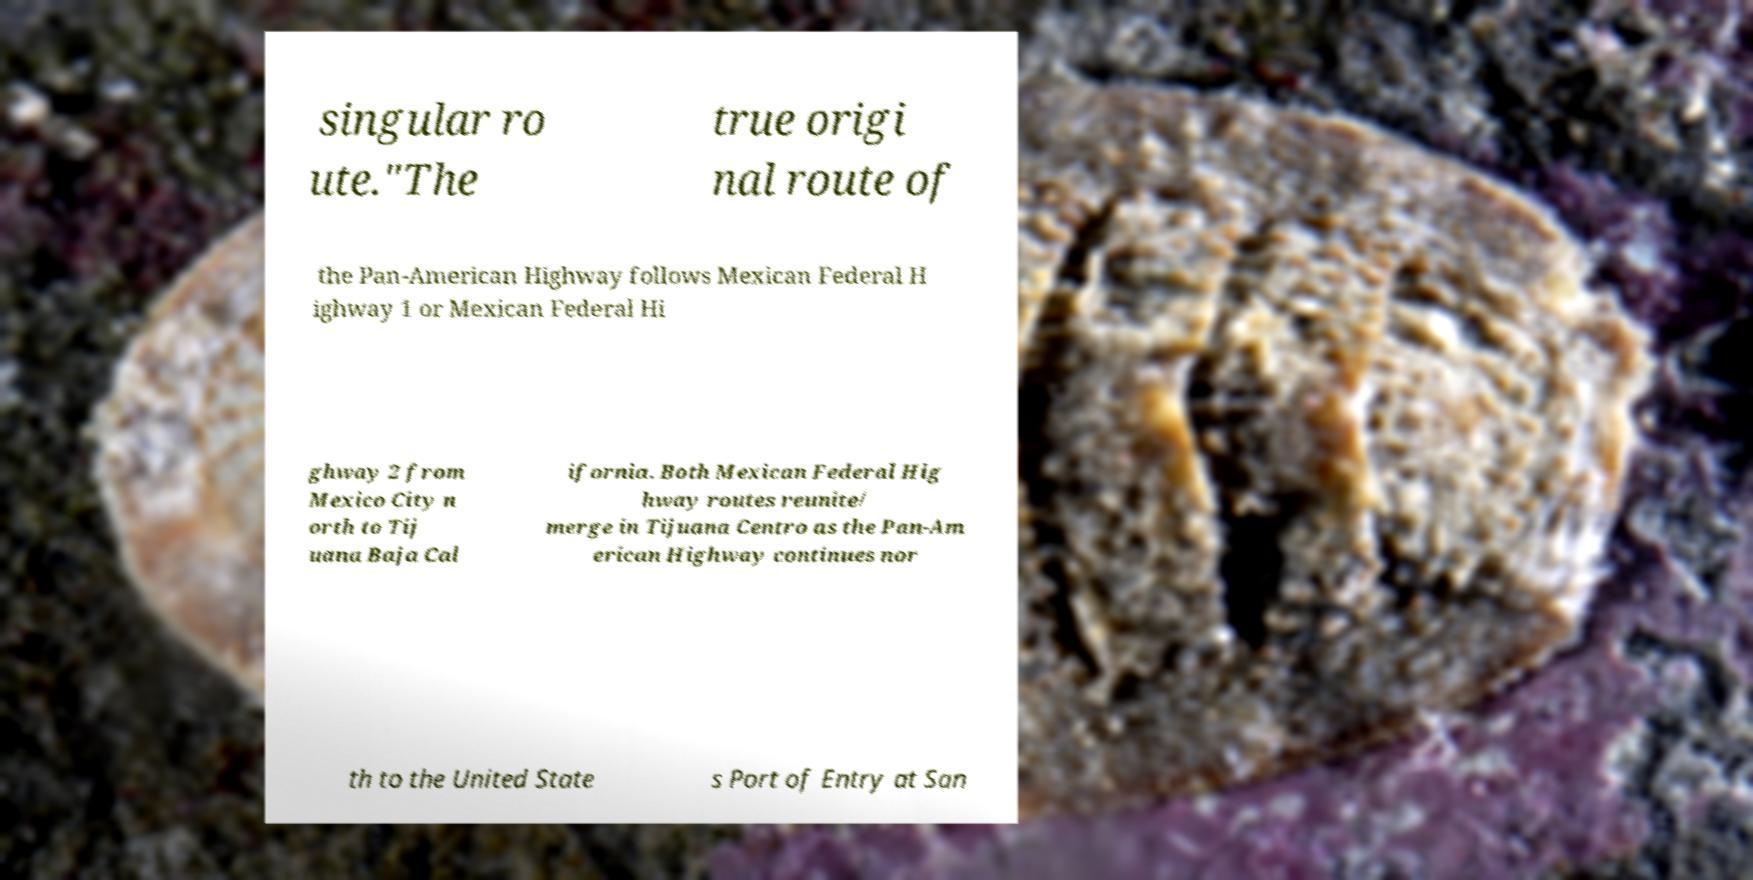What messages or text are displayed in this image? I need them in a readable, typed format. singular ro ute."The true origi nal route of the Pan-American Highway follows Mexican Federal H ighway 1 or Mexican Federal Hi ghway 2 from Mexico City n orth to Tij uana Baja Cal ifornia. Both Mexican Federal Hig hway routes reunite/ merge in Tijuana Centro as the Pan-Am erican Highway continues nor th to the United State s Port of Entry at San 